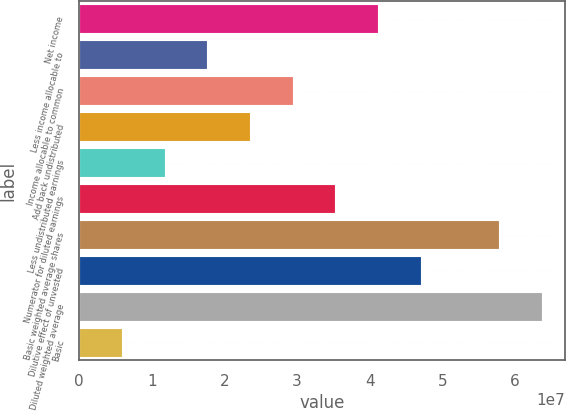<chart> <loc_0><loc_0><loc_500><loc_500><bar_chart><fcel>Net income<fcel>Less income allocable to<fcel>Income allocable to common<fcel>Add back undistributed<fcel>Less undistributed earnings<fcel>Numerator for diluted earnings<fcel>Basic weighted average shares<fcel>Dilutive effect of unvested<fcel>Diluted weighted average<fcel>Basic<nl><fcel>4.1153e+07<fcel>1.7637e+07<fcel>2.9395e+07<fcel>2.3516e+07<fcel>1.1758e+07<fcel>3.5274e+07<fcel>5.78392e+07<fcel>4.7032e+07<fcel>6.37182e+07<fcel>5.879e+06<nl></chart> 